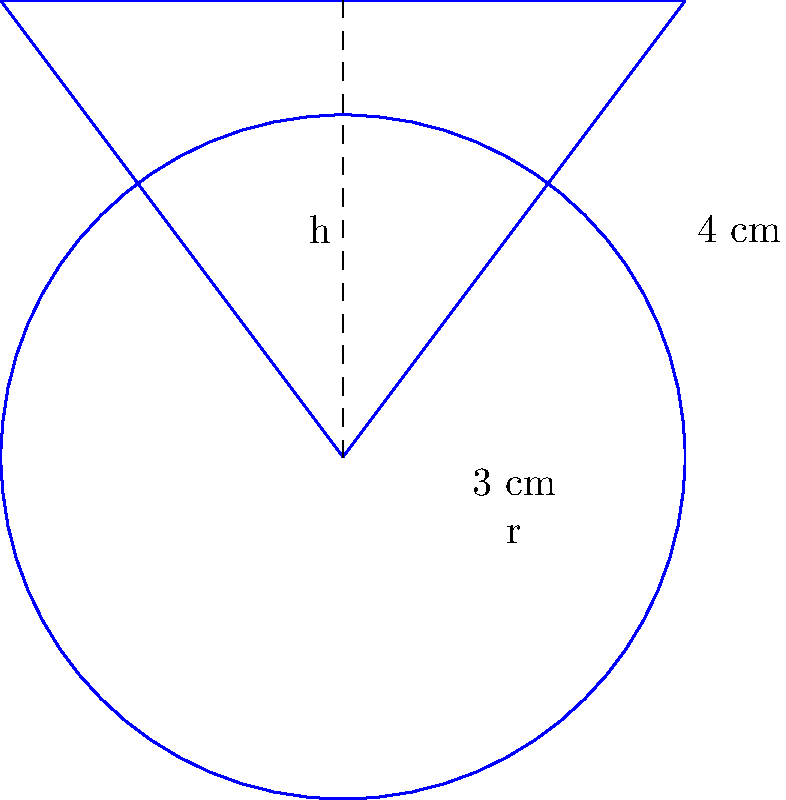The cash register at the dealership contains a cone-shaped pile of coins. The base of the cone has a radius of 3 cm, and the height of the cone is 4 cm. Calculate the volume of this pile of coins in cubic centimeters. Round your answer to two decimal places. To find the volume of a cone, we use the formula:

$$V = \frac{1}{3}\pi r^2 h$$

Where:
$V$ = volume
$r$ = radius of the base
$h$ = height of the cone

Given:
$r = 3$ cm
$h = 4$ cm

Let's substitute these values into the formula:

$$V = \frac{1}{3}\pi (3\text{ cm})^2 (4\text{ cm})$$

$$V = \frac{1}{3}\pi (9\text{ cm}^2) (4\text{ cm})$$

$$V = \frac{1}{3}\pi (36\text{ cm}^3)$$

$$V = 12\pi\text{ cm}^3$$

Now, let's calculate this value and round to two decimal places:

$$V = 12 * 3.14159... \approx 37.70\text{ cm}^3$$

Therefore, the volume of the cone-shaped pile of coins is approximately 37.70 cubic centimeters.
Answer: 37.70 cm³ 